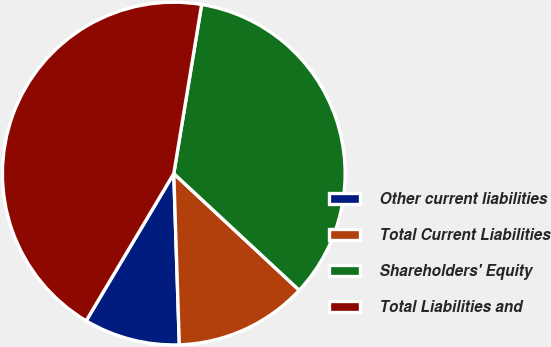Convert chart. <chart><loc_0><loc_0><loc_500><loc_500><pie_chart><fcel>Other current liabilities<fcel>Total Current Liabilities<fcel>Shareholders' Equity<fcel>Total Liabilities and<nl><fcel>9.06%<fcel>12.56%<fcel>34.32%<fcel>44.05%<nl></chart> 